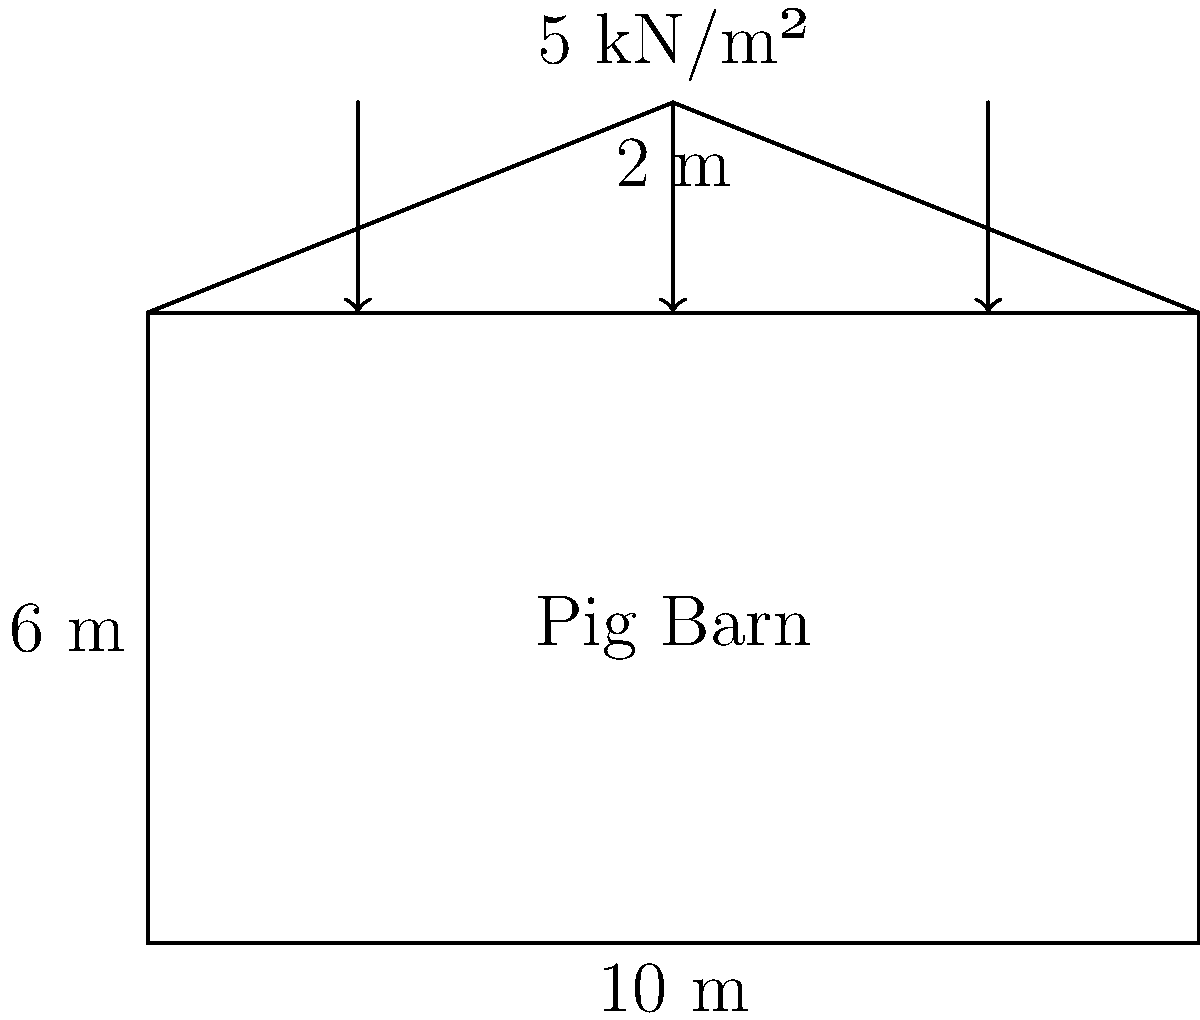A pig barn is designed with dimensions of 10 m width, 6 m height to the eaves, and a roof peak 2 m above the eaves. The roof is subject to a uniformly distributed load of 5 kN/m². Assuming the roof trusses are spaced at 2 m intervals, what is the total load that each truss must support? To calculate the total load that each truss must support, we need to follow these steps:

1. Calculate the roof span:
   The roof span is the width of the barn, which is 10 m.

2. Calculate the roof pitch:
   The roof rises 2 m over half the span (5 m), so the pitch is 2/5 = 0.4 or 21.8°.

3. Calculate the roof surface area supported by each truss:
   - The trusses are spaced at 2 m intervals.
   - The sloped length of the roof can be calculated using the Pythagorean theorem:
     $\sqrt{5^2 + 2^2} = \sqrt{29} \approx 5.39$ m
   - Area supported by each truss = $5.39 \text{ m} \times 2 \text{ m} = 10.78 \text{ m}^2$

4. Calculate the total load on each truss:
   - Load per square meter = 5 kN/m²
   - Total load = Area × Load per square meter
   - Total load = $10.78 \text{ m}^2 \times 5 \text{ kN/m}^2 = 53.9 \text{ kN}$

Therefore, each truss must support approximately 53.9 kN.
Answer: 53.9 kN 